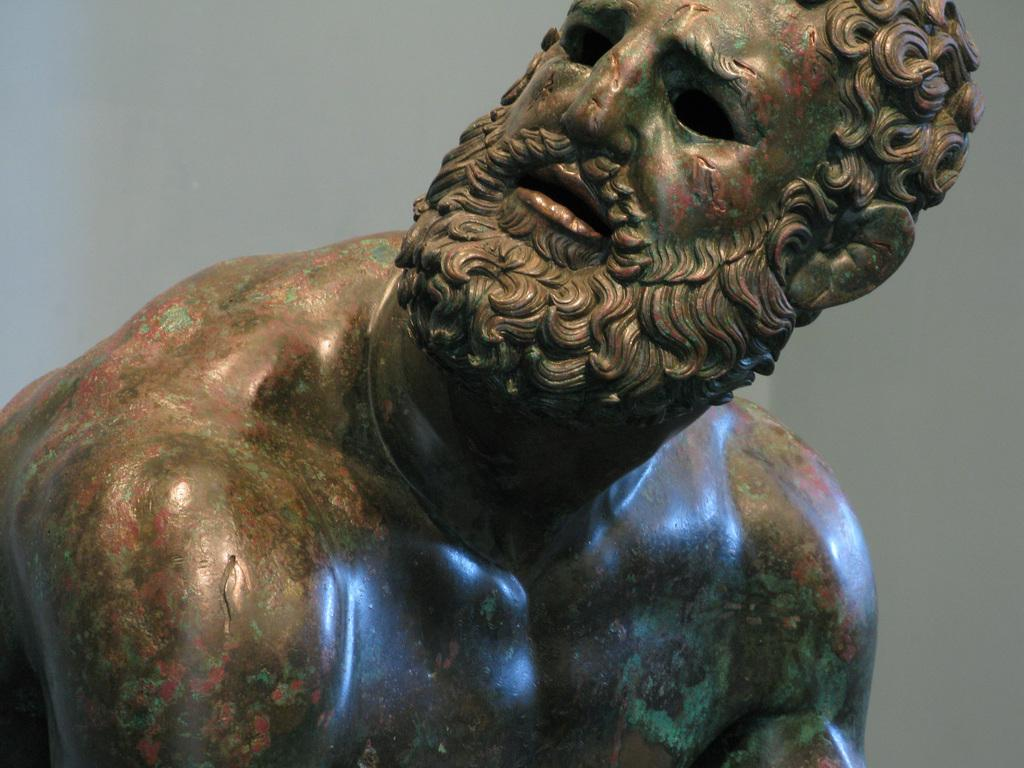What is the main subject of the image? There is a sculpture in the image. Can you describe the setting of the image? There is a wall in the background of the image. How many pairs of shoes are visible in the image? There are no shoes visible in the image; it features a sculpture and a wall in the background. What type of beetle can be seen crawling on the sculpture in the image? There is no beetle present in the image; it only features a sculpture and a wall in the background. 